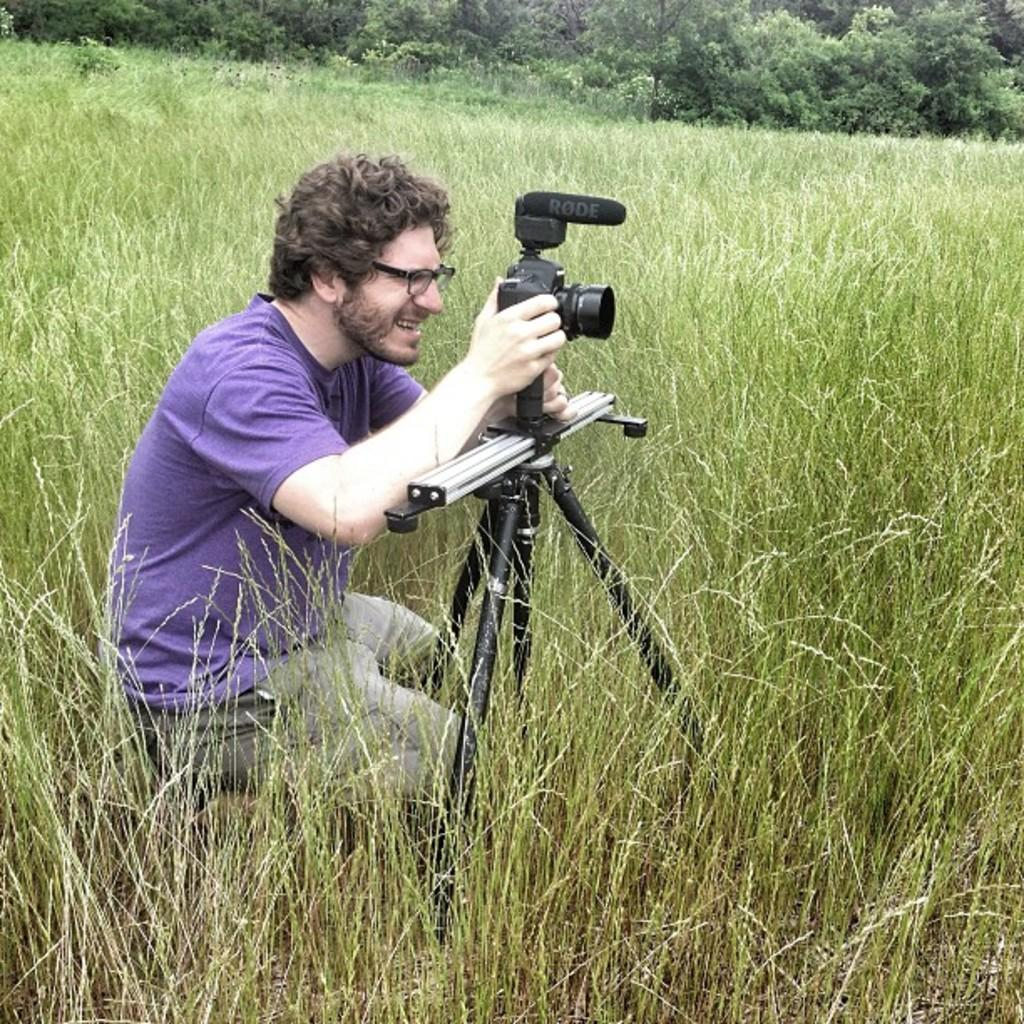Who or what is in the image? There is a person in the image. Where is the person located? The person is on the grass. What is the person holding in the image? The person is holding a tripod. What can be seen in the background of the image? There are trees visible in the background of the image. How many robins are nesting in the trees in the image? There are no robins or nests visible in the image; only a person, grass, a tripod, and trees are present. 